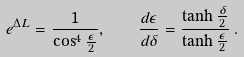Convert formula to latex. <formula><loc_0><loc_0><loc_500><loc_500>e ^ { \Delta L } = \frac { 1 } { \cos ^ { 4 } \frac { \epsilon } { 2 } } , \quad \frac { d \epsilon } { d \delta } = \frac { \tanh \frac { \delta } { 2 } } { \tanh \frac { \epsilon } { 2 } } \, .</formula> 